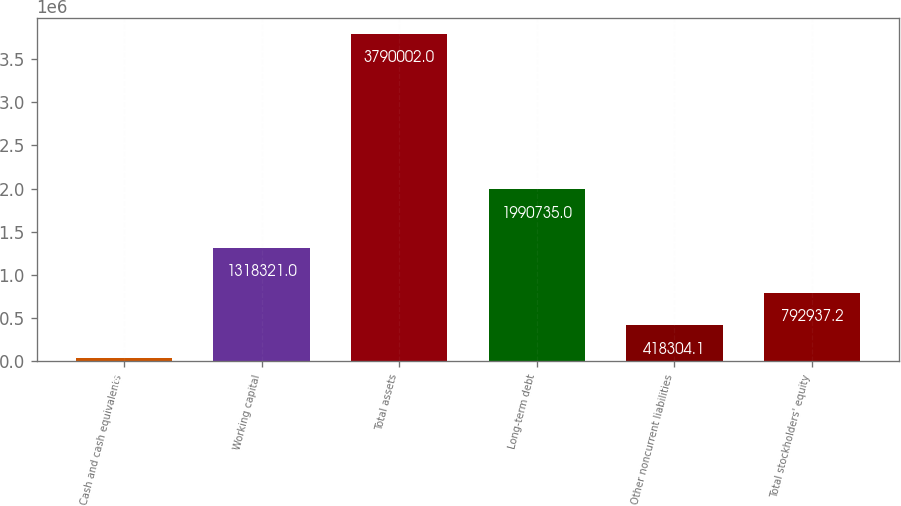<chart> <loc_0><loc_0><loc_500><loc_500><bar_chart><fcel>Cash and cash equivalents<fcel>Working capital<fcel>Total assets<fcel>Long-term debt<fcel>Other noncurrent liabilities<fcel>Total stockholders' equity<nl><fcel>43671<fcel>1.31832e+06<fcel>3.79e+06<fcel>1.99074e+06<fcel>418304<fcel>792937<nl></chart> 